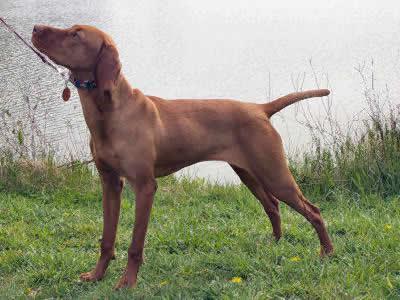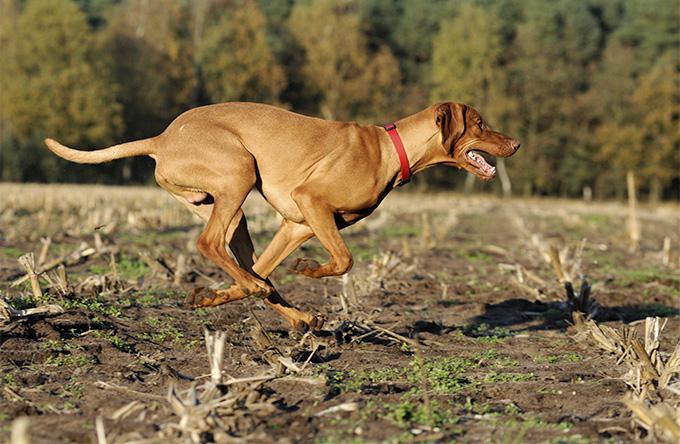The first image is the image on the left, the second image is the image on the right. Given the left and right images, does the statement "The dog in the image on the left is wearing a collar." hold true? Answer yes or no. Yes. The first image is the image on the left, the second image is the image on the right. For the images displayed, is the sentence "The left image features a solid-colored hound in leftward-facing profile with its tail extended out." factually correct? Answer yes or no. Yes. 